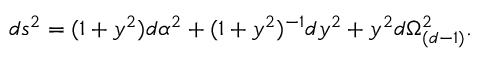<formula> <loc_0><loc_0><loc_500><loc_500>d s ^ { 2 } = ( 1 + y ^ { 2 } ) d \alpha ^ { 2 } + ( 1 + y ^ { 2 } ) ^ { - 1 } d y ^ { 2 } + y ^ { 2 } d \Omega _ { ( d - 1 ) } ^ { 2 } .</formula> 